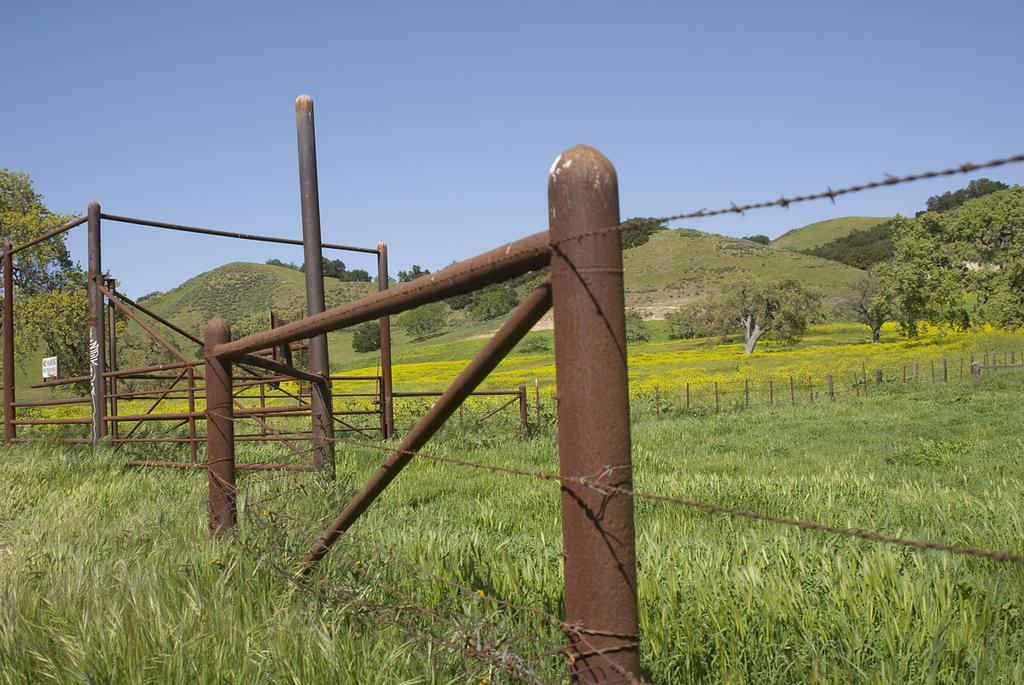What type of structure can be seen in the image? There is a fence in the image. What other objects are present in the image? There are poles and a small board attached to a pole in the image. What is the main setting of the image? The image features a field. What can be seen in the background of the image? There are trees, grass, a mountain, and the sky visible in the background of the image. How many boys are surfing on the waves in the image? There are no boys or waves present in the image. What type of steel is used to construct the fence in the image? There is no information about the type of steel used in the fence, and the image does not show any steel. 